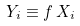<formula> <loc_0><loc_0><loc_500><loc_500>Y _ { i } \equiv f \, X _ { i }</formula> 